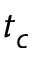Convert formula to latex. <formula><loc_0><loc_0><loc_500><loc_500>t _ { c }</formula> 